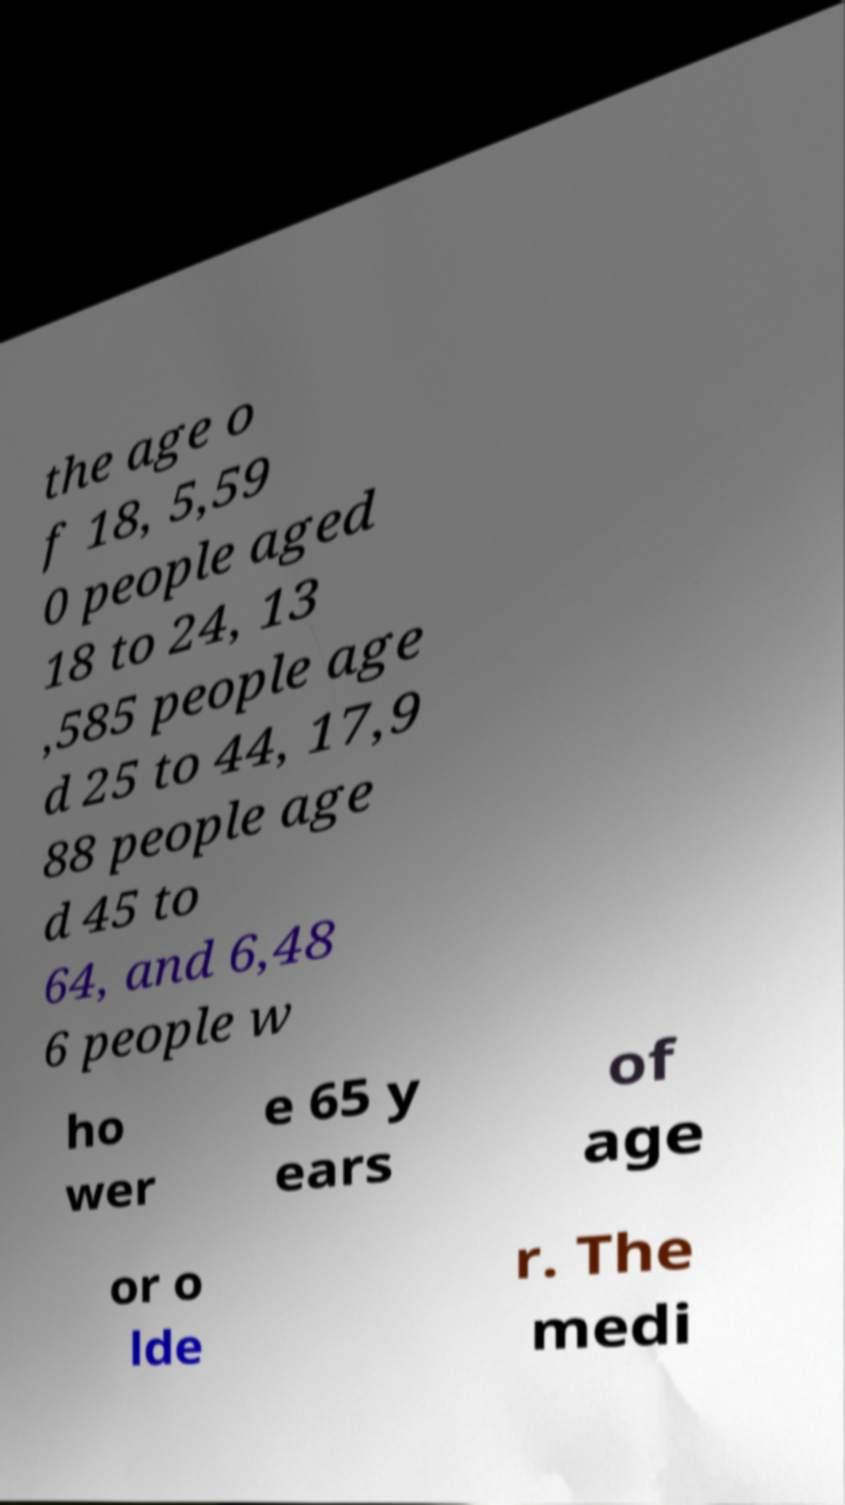Can you read and provide the text displayed in the image?This photo seems to have some interesting text. Can you extract and type it out for me? the age o f 18, 5,59 0 people aged 18 to 24, 13 ,585 people age d 25 to 44, 17,9 88 people age d 45 to 64, and 6,48 6 people w ho wer e 65 y ears of age or o lde r. The medi 